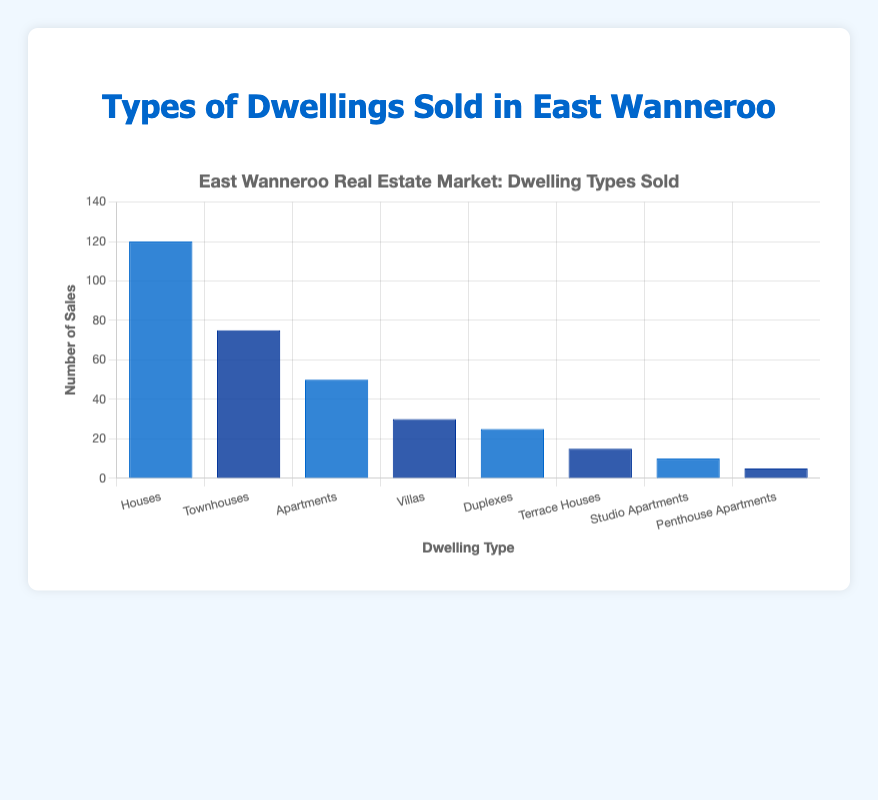Which dwelling type has the highest number of sales? The bar chart visually shows that the height of the bar for "Houses" is the tallest, indicating the highest number of sales.
Answer: Houses What is the total number of sales for all dwelling types combined? Adding the sales numbers for all dwelling types (120 + 75 + 50 + 30 + 25 + 15 + 10 + 5) gives a total of 330.
Answer: 330 How many more houses were sold compared to penthouse apartments? The number of houses sold is 120 and penthouse apartments is 5. The difference is 120 - 5 = 115.
Answer: 115 Between townhouses and apartments, which had more sales and by how much? Townhouses had 75 sales and apartments had 50 sales. The difference is 75 - 50 = 25.
Answer: Townhouses by 25 Which two dwelling types have the least number of sales? The bar chart shows the shortest bars for "Studio Apartments" and "Penthouse Apartments," with 10 and 5 sales respectively.
Answer: Studio Apartments and Penthouse Apartments What is the average number of sales per dwelling type? The total number of sales is 330, and there are 8 dwelling types. The average is 330 / 8 = 41.25.
Answer: 41.25 Are there more sales of townhouses and duplexes combined than houses? The combined sales for townhouses and duplexes is 75 + 25 = 100, which is less than 120 (the number of houses sold).
Answer: No What is the difference in sales between the dwelling type with the most sales and the dwelling type with the least sales? Houses have the most sales at 120, and penthouse apartments have the least at 5. The difference is 120 - 5 = 115.
Answer: 115 Which dwelling types have sales between 20 and 80? The bars for Townhouses (75), Apartments (50), Villas (30), and Duplexes (25) fall within the range of 20 to 80.
Answer: Townhouses, Apartments, Villas, Duplexes If studio apartments and terrace houses sales doubled, what would their new totals be? Studio apartments initially have 10 sales and would have 10*2 = 20. Terrace houses initially have 15 sales and would have 15*2 = 30.
Answer: 20 and 30, respectively 